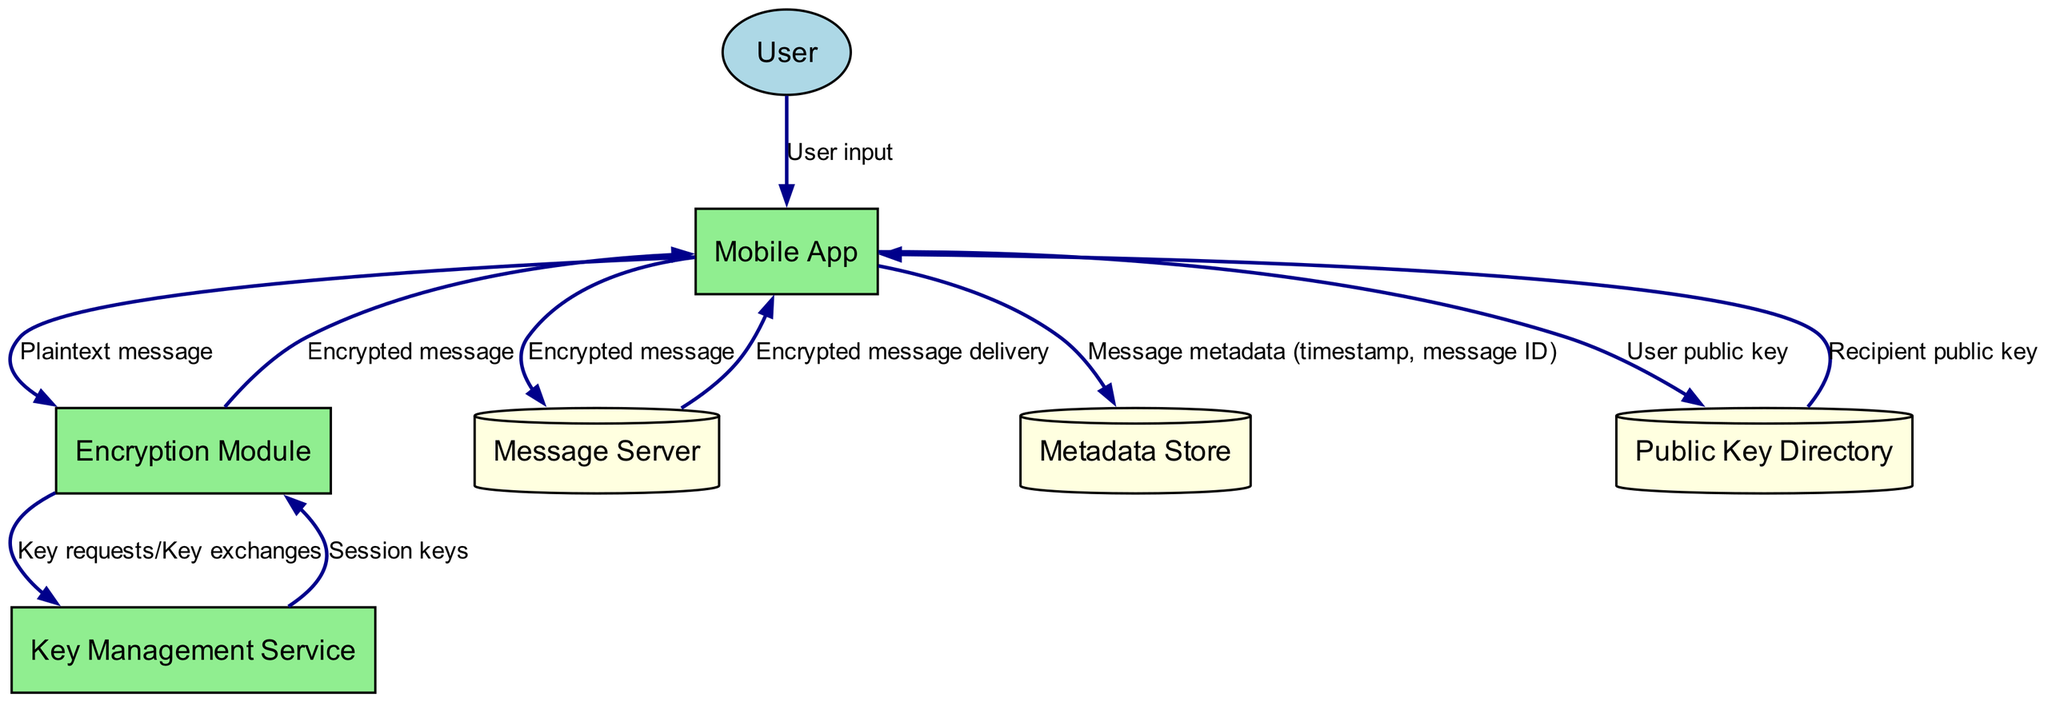What is the external entity in this diagram? The external entity in the diagram is the "User," which represents a digital nomad using the encrypted messaging app.
Answer: User How many processes are present in the diagram? The diagram contains three processes: "Mobile App," "Encryption Module," and "Key Management Service." Counting these entities gives a total of three processes.
Answer: 3 Which process is responsible for encrypting and decrypting messages? The "Encryption Module" is the process in the diagram designated to handle the encryption and decryption of messages, as stated in its description.
Answer: Encryption Module What data is sent from the Mobile App to the Message Server? The "Mobile App" sends an "Encrypted message" to the "Message Server," as indicated by the data flow between these two nodes.
Answer: Encrypted message What data does the Public Key Directory provide to the Mobile App? The "Public Key Directory" provides the "Recipient public key" to the "Mobile App," allowing secure communication to be established.
Answer: Recipient public key What occurs first in the process flow after the User inputs a message? After the User inputs a message, the first process in the flow is the "Mobile App," which receives the user input before any other interactions happen.
Answer: Mobile App How many data flows are there in the diagram? There are ten data flows present in the diagram, showing various interactions between the nodes.
Answer: 10 Which component manages cryptographic keys? The "Key Management Service" is the component responsible for managing the cryptographic keys used for encryption and decryption in the app.
Answer: Key Management Service What type of store is the Message Server? The "Message Server" is classified as a "Data Store" within the diagram, indicated by its description and representation as a cylinder shape.
Answer: Data Store What data is stored in the Metadata Store? The "Metadata Store" stores "message metadata (timestamp, message ID)," but does not contain any message content, as specified in the data flows.
Answer: Message metadata (timestamp, message ID) 